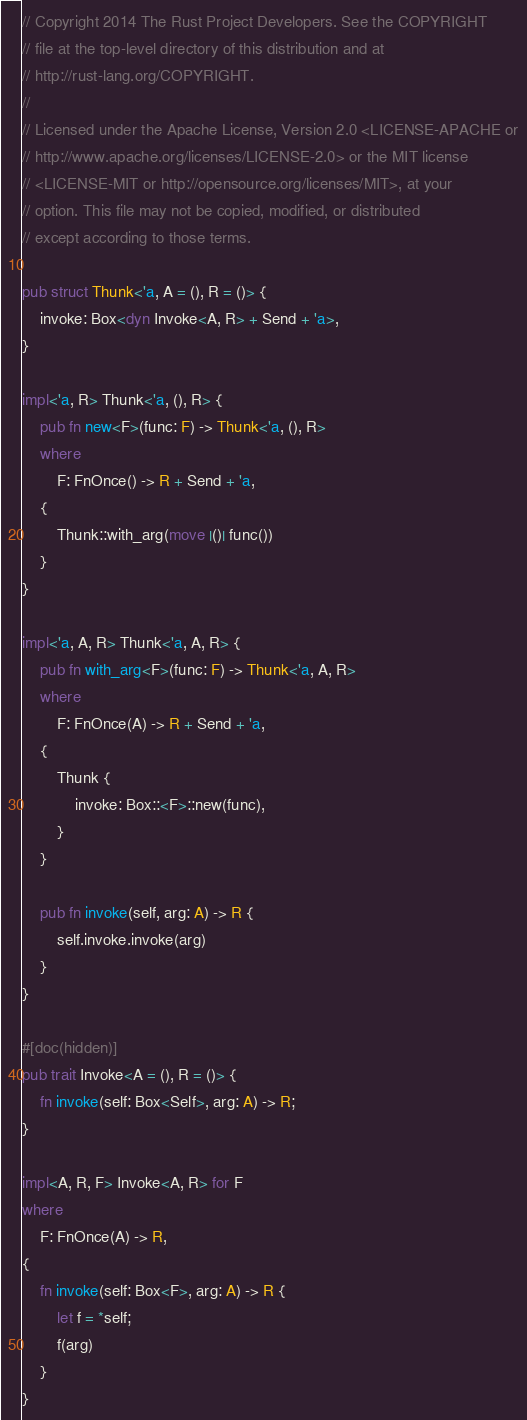Convert code to text. <code><loc_0><loc_0><loc_500><loc_500><_Rust_>// Copyright 2014 The Rust Project Developers. See the COPYRIGHT
// file at the top-level directory of this distribution and at
// http://rust-lang.org/COPYRIGHT.
//
// Licensed under the Apache License, Version 2.0 <LICENSE-APACHE or
// http://www.apache.org/licenses/LICENSE-2.0> or the MIT license
// <LICENSE-MIT or http://opensource.org/licenses/MIT>, at your
// option. This file may not be copied, modified, or distributed
// except according to those terms.

pub struct Thunk<'a, A = (), R = ()> {
    invoke: Box<dyn Invoke<A, R> + Send + 'a>,
}

impl<'a, R> Thunk<'a, (), R> {
    pub fn new<F>(func: F) -> Thunk<'a, (), R>
    where
        F: FnOnce() -> R + Send + 'a,
    {
        Thunk::with_arg(move |()| func())
    }
}

impl<'a, A, R> Thunk<'a, A, R> {
    pub fn with_arg<F>(func: F) -> Thunk<'a, A, R>
    where
        F: FnOnce(A) -> R + Send + 'a,
    {
        Thunk {
            invoke: Box::<F>::new(func),
        }
    }

    pub fn invoke(self, arg: A) -> R {
        self.invoke.invoke(arg)
    }
}

#[doc(hidden)]
pub trait Invoke<A = (), R = ()> {
    fn invoke(self: Box<Self>, arg: A) -> R;
}

impl<A, R, F> Invoke<A, R> for F
where
    F: FnOnce(A) -> R,
{
    fn invoke(self: Box<F>, arg: A) -> R {
        let f = *self;
        f(arg)
    }
}
</code> 